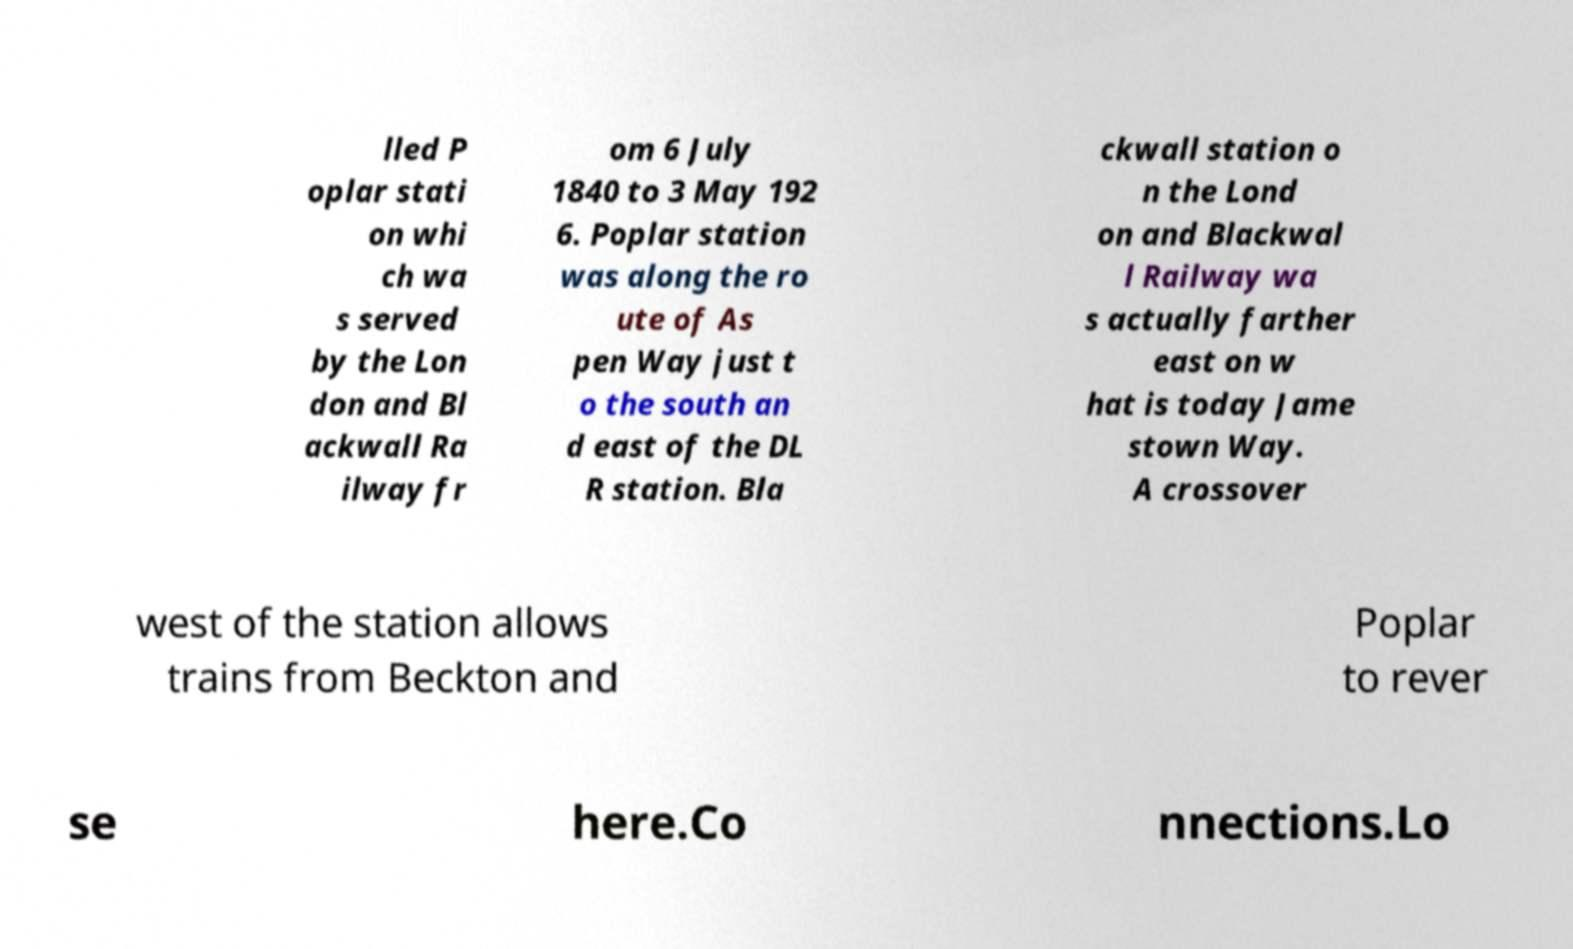Can you accurately transcribe the text from the provided image for me? lled P oplar stati on whi ch wa s served by the Lon don and Bl ackwall Ra ilway fr om 6 July 1840 to 3 May 192 6. Poplar station was along the ro ute of As pen Way just t o the south an d east of the DL R station. Bla ckwall station o n the Lond on and Blackwal l Railway wa s actually farther east on w hat is today Jame stown Way. A crossover west of the station allows trains from Beckton and Poplar to rever se here.Co nnections.Lo 